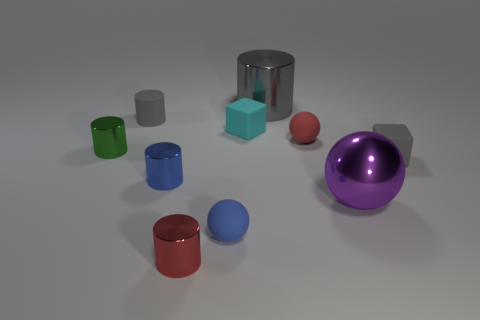Is the big metal cylinder the same color as the matte cylinder?
Your answer should be very brief. Yes. There is a small red cylinder that is on the right side of the small gray thing that is to the left of the red metal thing; what number of small red cylinders are in front of it?
Your response must be concise. 0. What is the shape of the tiny shiny thing that is in front of the small green thing and behind the tiny red metallic thing?
Ensure brevity in your answer.  Cylinder. Are there fewer big metal balls that are right of the purple thing than cyan objects?
Provide a succinct answer. Yes. How many small things are gray metallic cubes or red metallic things?
Your answer should be very brief. 1. The gray metallic cylinder has what size?
Keep it short and to the point. Large. Is there any other thing that has the same material as the cyan block?
Provide a short and direct response. Yes. There is a large purple metallic sphere; what number of purple shiny things are in front of it?
Offer a terse response. 0. The blue object that is the same shape as the purple metallic thing is what size?
Give a very brief answer. Small. What is the size of the cylinder that is both behind the gray matte cube and in front of the cyan matte object?
Keep it short and to the point. Small. 